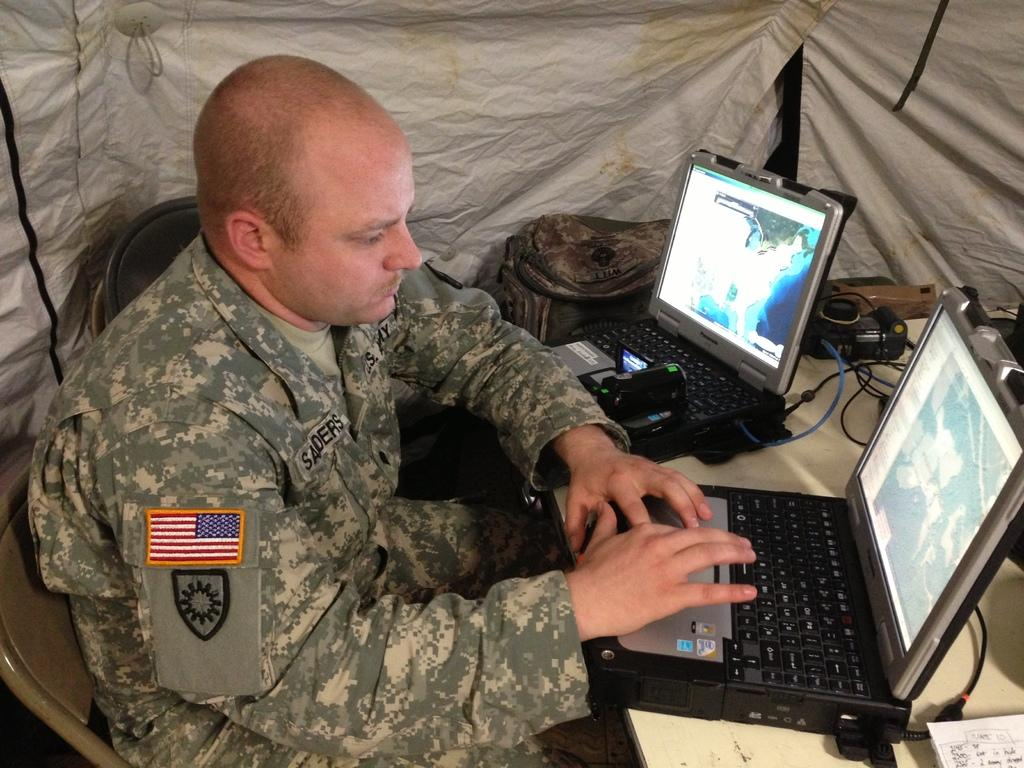<image>
Present a compact description of the photo's key features. Soldier with the name Sanders using a laptop. 